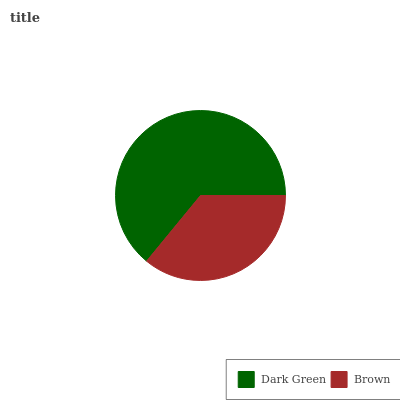Is Brown the minimum?
Answer yes or no. Yes. Is Dark Green the maximum?
Answer yes or no. Yes. Is Brown the maximum?
Answer yes or no. No. Is Dark Green greater than Brown?
Answer yes or no. Yes. Is Brown less than Dark Green?
Answer yes or no. Yes. Is Brown greater than Dark Green?
Answer yes or no. No. Is Dark Green less than Brown?
Answer yes or no. No. Is Dark Green the high median?
Answer yes or no. Yes. Is Brown the low median?
Answer yes or no. Yes. Is Brown the high median?
Answer yes or no. No. Is Dark Green the low median?
Answer yes or no. No. 